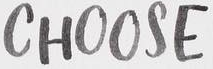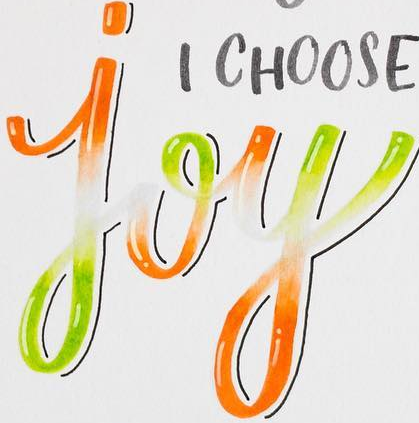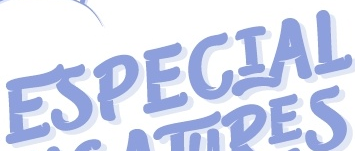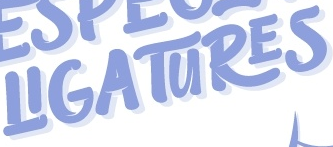What text is displayed in these images sequentially, separated by a semicolon? CHOOSE; joy; ESPECIAL; LIGATURES 